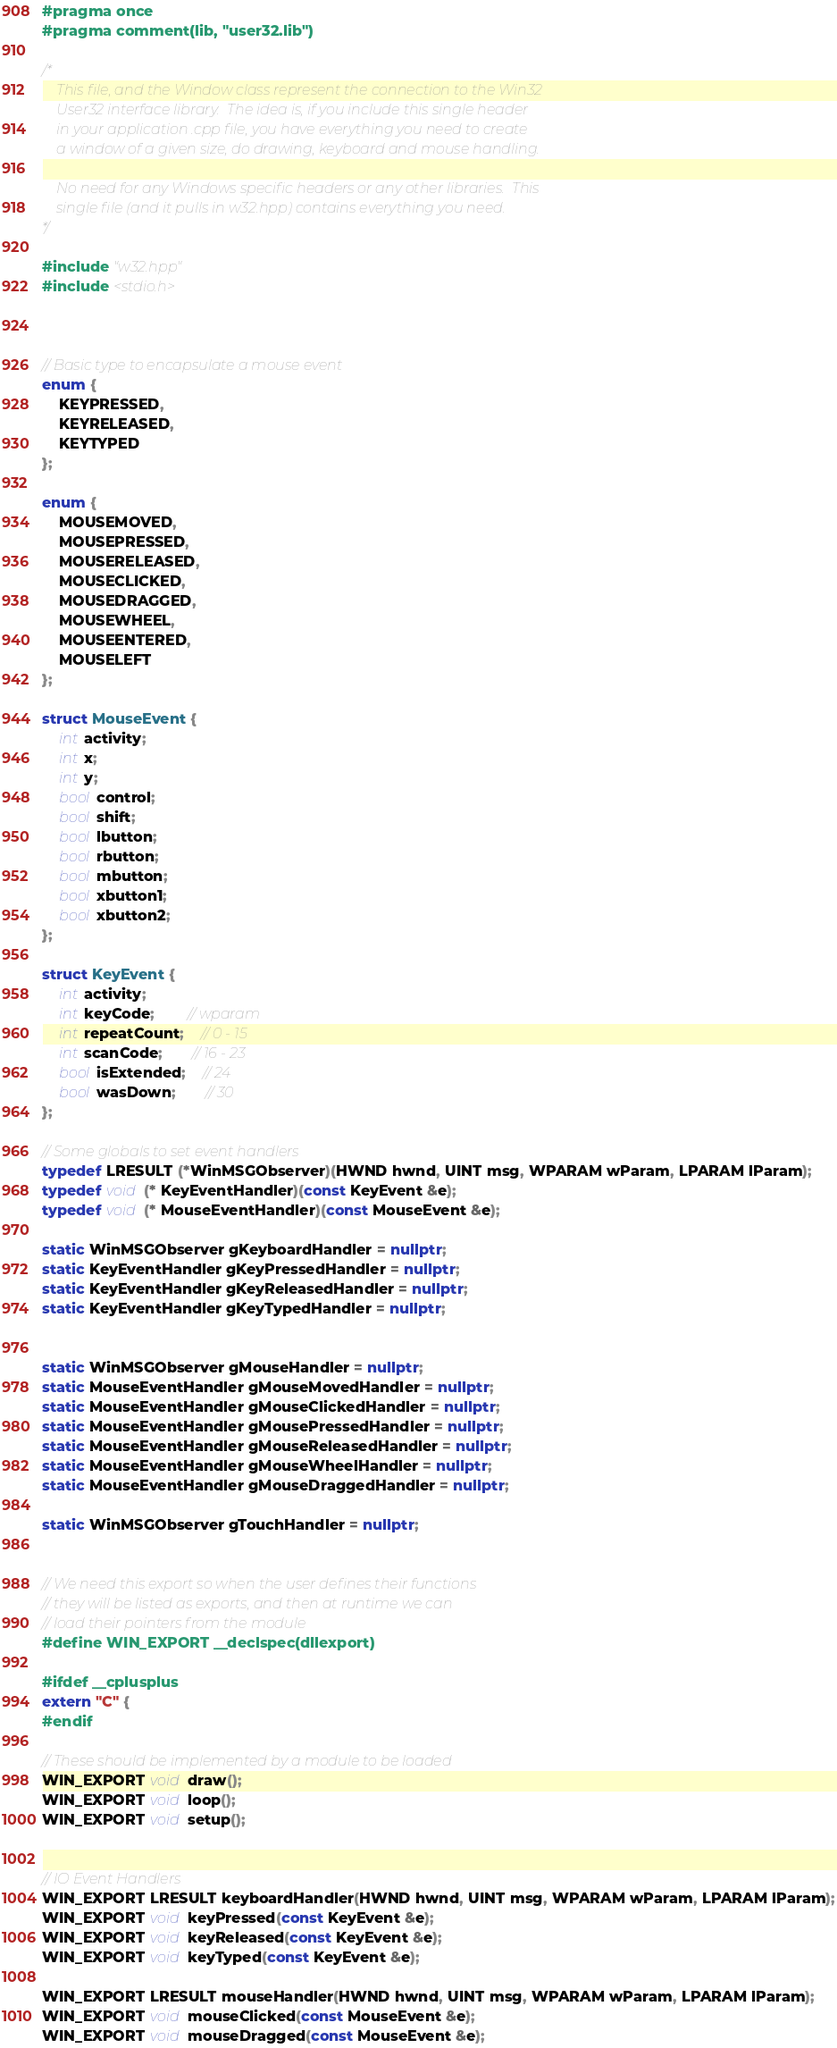Convert code to text. <code><loc_0><loc_0><loc_500><loc_500><_C++_>#pragma once
#pragma comment(lib, "user32.lib")

/*
    This file, and the Window class represent the connection to the Win32 
    User32 interface library.  The idea is, if you include this single header
    in your application .cpp file, you have everything you need to create 
    a window of a given size, do drawing, keyboard and mouse handling.

    No need for any Windows specific headers or any other libraries.  This
    single file (and it pulls in w32.hpp) contains everything you need.
*/

#include "w32.hpp"
#include <stdio.h>



// Basic type to encapsulate a mouse event
enum {
    KEYPRESSED,
    KEYRELEASED,
    KEYTYPED
};

enum {
    MOUSEMOVED,
    MOUSEPRESSED,
    MOUSERELEASED,
    MOUSECLICKED,
    MOUSEDRAGGED,
    MOUSEWHEEL,
    MOUSEENTERED,
    MOUSELEFT
};

struct MouseEvent {
    int activity;
    int x;
    int y;
    bool control;
    bool shift;
    bool lbutton;
    bool rbutton;
    bool mbutton;
    bool xbutton1;
    bool xbutton2;
};

struct KeyEvent {
    int activity;
    int keyCode;        // wparam
    int repeatCount;    // 0 - 15
    int scanCode;       // 16 - 23
    bool isExtended;    // 24
    bool wasDown;       // 30
};

// Some globals to set event handlers
typedef LRESULT (*WinMSGObserver)(HWND hwnd, UINT msg, WPARAM wParam, LPARAM lParam);
typedef void (* KeyEventHandler)(const KeyEvent &e);
typedef void (* MouseEventHandler)(const MouseEvent &e);

static WinMSGObserver gKeyboardHandler = nullptr;
static KeyEventHandler gKeyPressedHandler = nullptr;
static KeyEventHandler gKeyReleasedHandler = nullptr;
static KeyEventHandler gKeyTypedHandler = nullptr;


static WinMSGObserver gMouseHandler = nullptr;
static MouseEventHandler gMouseMovedHandler = nullptr;
static MouseEventHandler gMouseClickedHandler = nullptr;
static MouseEventHandler gMousePressedHandler = nullptr;
static MouseEventHandler gMouseReleasedHandler = nullptr;
static MouseEventHandler gMouseWheelHandler = nullptr;
static MouseEventHandler gMouseDraggedHandler = nullptr;

static WinMSGObserver gTouchHandler = nullptr;


// We need this export so when the user defines their functions
// they will be listed as exports, and then at runtime we can 
// load their pointers from the module
#define WIN_EXPORT __declspec(dllexport)

#ifdef __cplusplus
extern "C" {
#endif

// These should be implemented by a module to be loaded
WIN_EXPORT void draw();
WIN_EXPORT void loop();
WIN_EXPORT void setup();


// IO Event Handlers
WIN_EXPORT LRESULT keyboardHandler(HWND hwnd, UINT msg, WPARAM wParam, LPARAM lParam);
WIN_EXPORT void keyPressed(const KeyEvent &e);
WIN_EXPORT void keyReleased(const KeyEvent &e);
WIN_EXPORT void keyTyped(const KeyEvent &e);

WIN_EXPORT LRESULT mouseHandler(HWND hwnd, UINT msg, WPARAM wParam, LPARAM lParam);
WIN_EXPORT void mouseClicked(const MouseEvent &e);
WIN_EXPORT void mouseDragged(const MouseEvent &e);</code> 